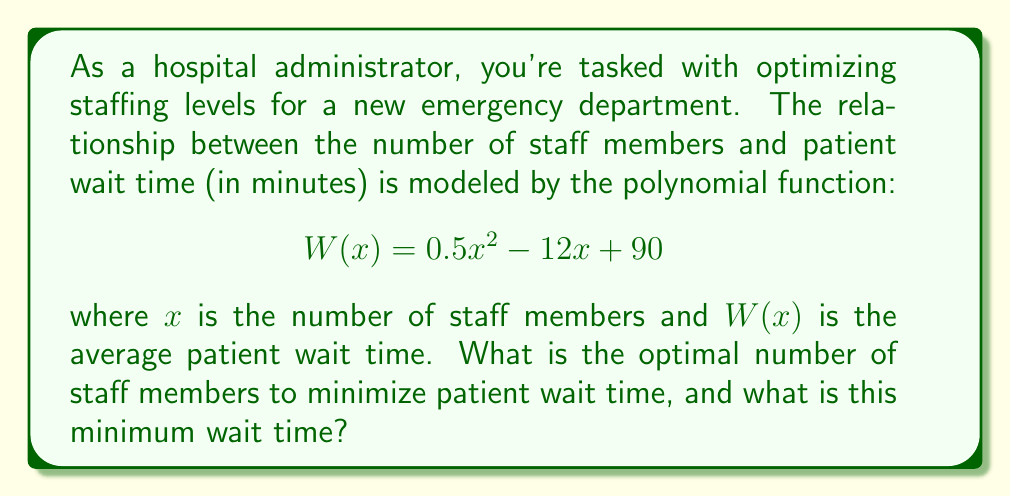What is the answer to this math problem? To solve this problem, we need to follow these steps:

1) The function $W(x)$ is a quadratic function, and its graph is a parabola. The minimum point of this parabola will give us the optimal number of staff members and the minimum wait time.

2) To find the minimum point, we need to find the vertex of the parabola. For a quadratic function in the form $f(x) = ax^2 + bx + c$, the x-coordinate of the vertex is given by $x = -\frac{b}{2a}$.

3) In our function $W(x) = 0.5x^2 - 12x + 90$, we have:
   $a = 0.5$
   $b = -12$
   $c = 90$

4) Let's calculate the x-coordinate of the vertex:

   $$x = -\frac{b}{2a} = -\frac{-12}{2(0.5)} = \frac{12}{1} = 12$$

5) This means the optimal number of staff members is 12.

6) To find the minimum wait time, we need to calculate $W(12)$:

   $$W(12) = 0.5(12)^2 - 12(12) + 90$$
   $$= 0.5(144) - 144 + 90$$
   $$= 72 - 144 + 90$$
   $$= 18$$

Therefore, the minimum wait time is 18 minutes.
Answer: The optimal number of staff members is 12, and the minimum wait time is 18 minutes. 